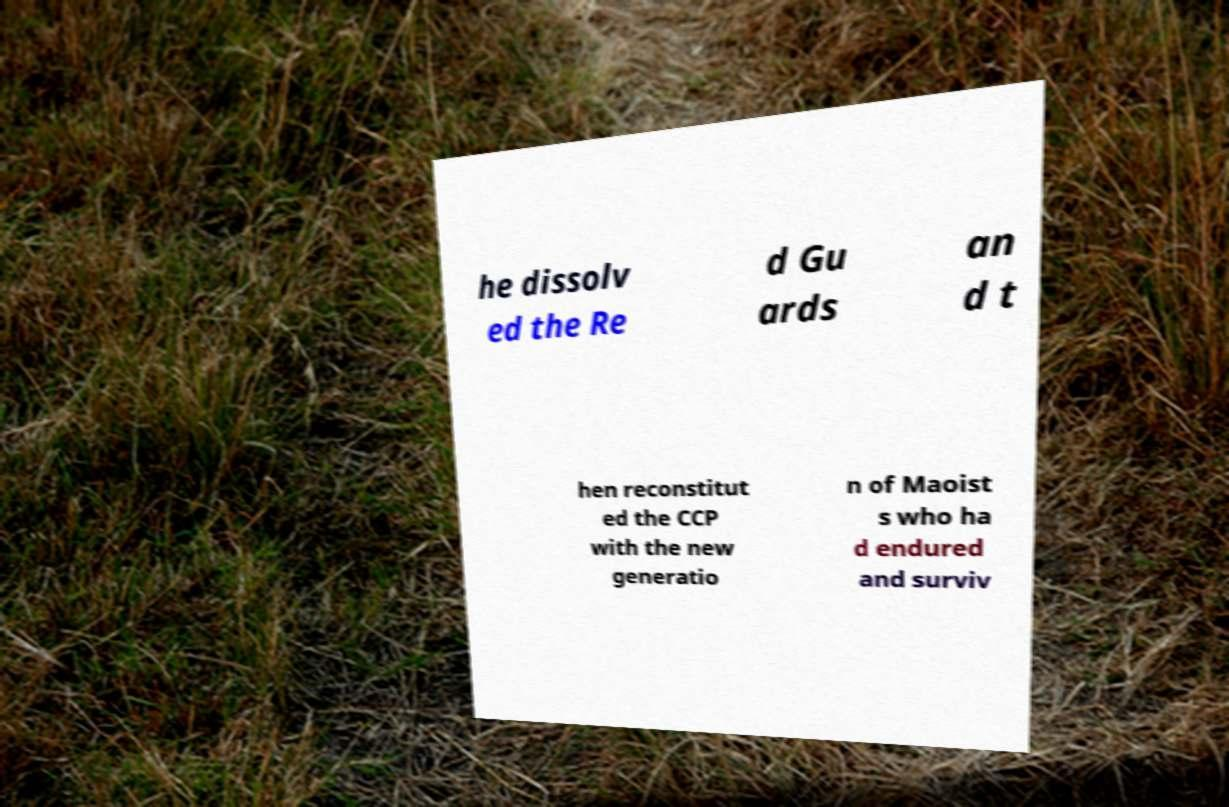Can you read and provide the text displayed in the image?This photo seems to have some interesting text. Can you extract and type it out for me? he dissolv ed the Re d Gu ards an d t hen reconstitut ed the CCP with the new generatio n of Maoist s who ha d endured and surviv 